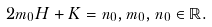<formula> <loc_0><loc_0><loc_500><loc_500>2 m _ { 0 } H + K = n _ { 0 } , m _ { 0 } , n _ { 0 } \in \mathbb { R } .</formula> 